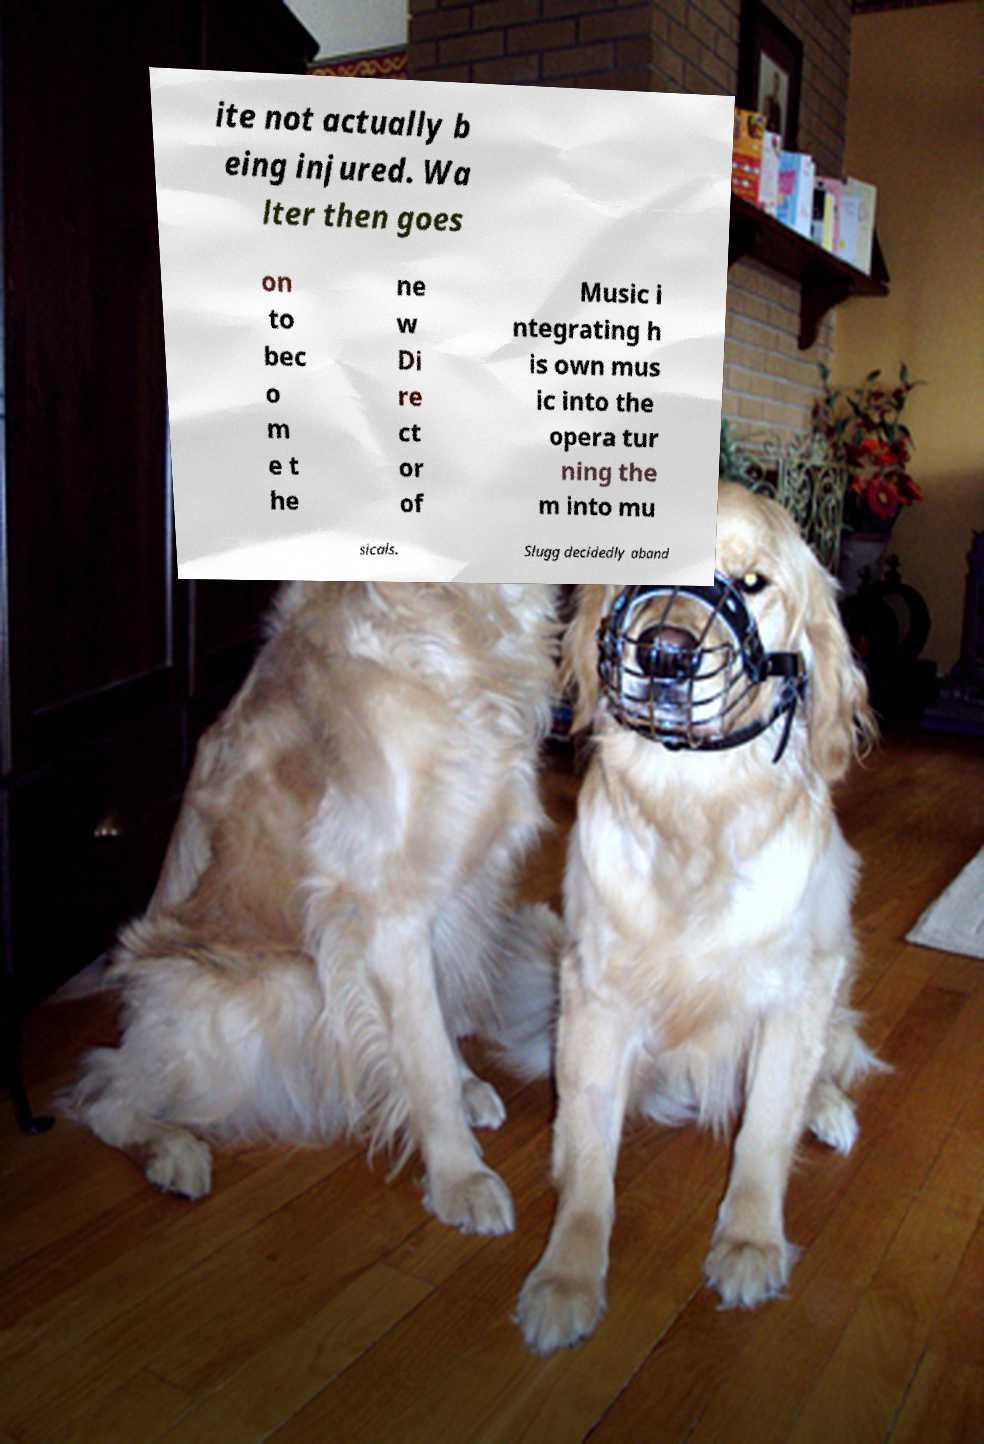Could you extract and type out the text from this image? ite not actually b eing injured. Wa lter then goes on to bec o m e t he ne w Di re ct or of Music i ntegrating h is own mus ic into the opera tur ning the m into mu sicals. Slugg decidedly aband 